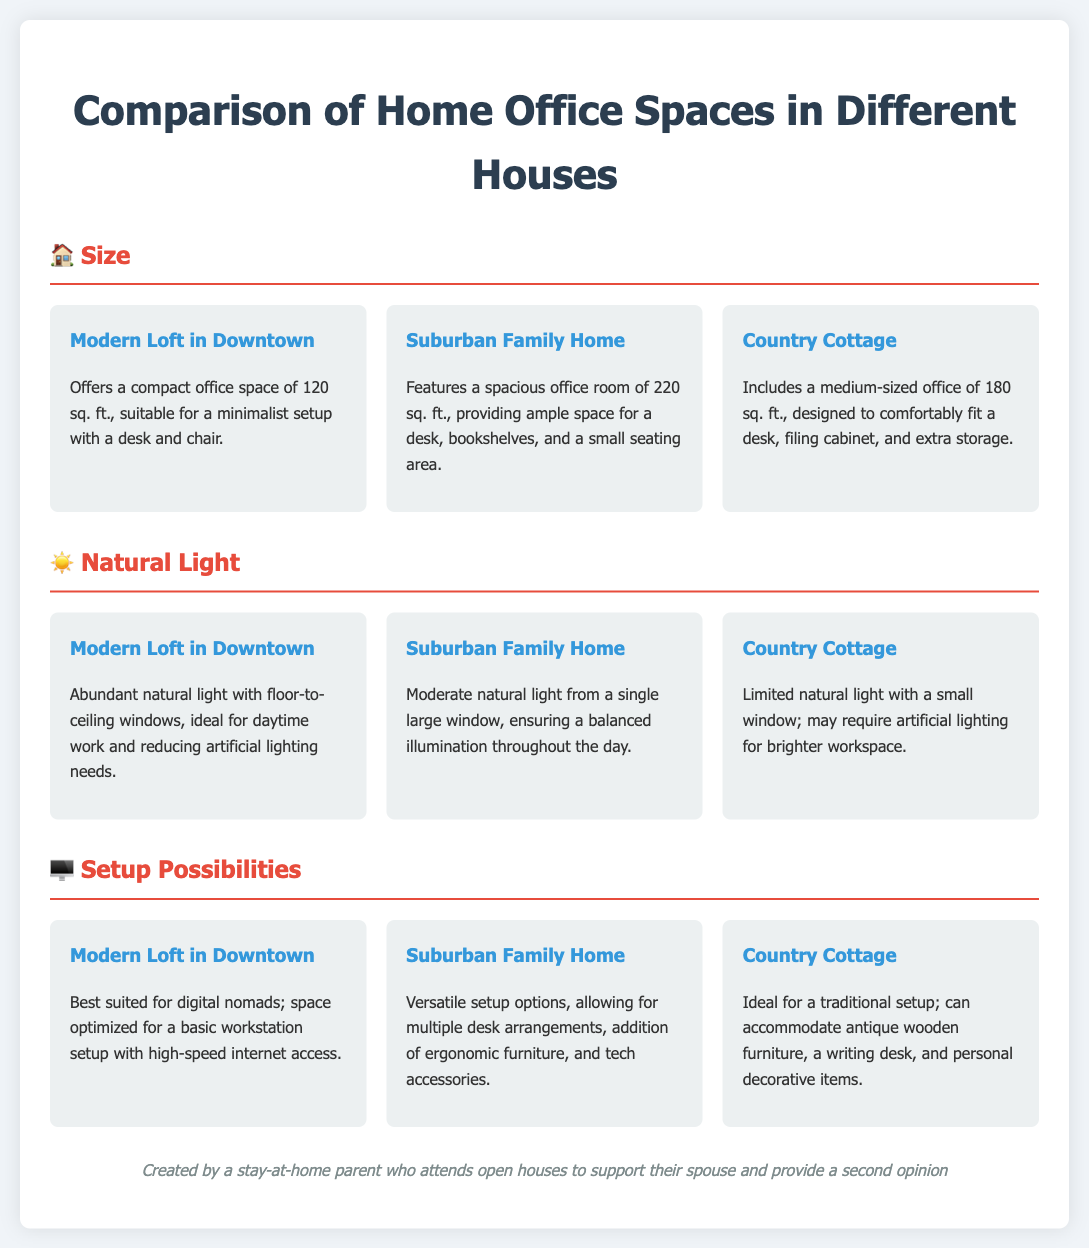What is the office space size of the Modern Loft? The office space size is provided as a specific measurement in the document, which is 120 sq. ft.
Answer: 120 sq. ft How much space does the Suburban Family Home offer for a home office? The document states the space available for an office in the Suburban Family Home as 220 sq. ft.
Answer: 220 sq. ft How many windows does the Suburban Family Home have? The document indicates the Suburban Family Home has a single large window that provides natural light.
Answer: One large window Which house has the most natural light? The comparison of natural light among the houses reveals that the Modern Loft in Downtown has abundant natural light.
Answer: Modern Loft in Downtown What kind of office setup is suggested for the Country Cottage? The document describes the Country Cottage setup as ideal for traditional arrangements, accommodating antique furniture.
Answer: Traditional setup What office size is suitable for the Country Cottage? The document specifies the office size as 180 sq. ft., which suits a comfortable workspace.
Answer: 180 sq. ft Which house is best for digital nomads? The Modern Loft in Downtown is noted in the document as best suited for digital nomads due to its optimized setup.
Answer: Modern Loft in Downtown What additional furniture can the Suburban Family Home accommodate? The document mentions that the Suburban Family Home allows for multiple desk arrangements and ergonomic furniture.
Answer: Multiple desk arrangements What feature is highlighted for the Modern Loft in terms of workspace brightness? The feature highlighted for the Modern Loft is its floor-to-ceiling windows, which provide abundant natural light.
Answer: Floor-to-ceiling windows 